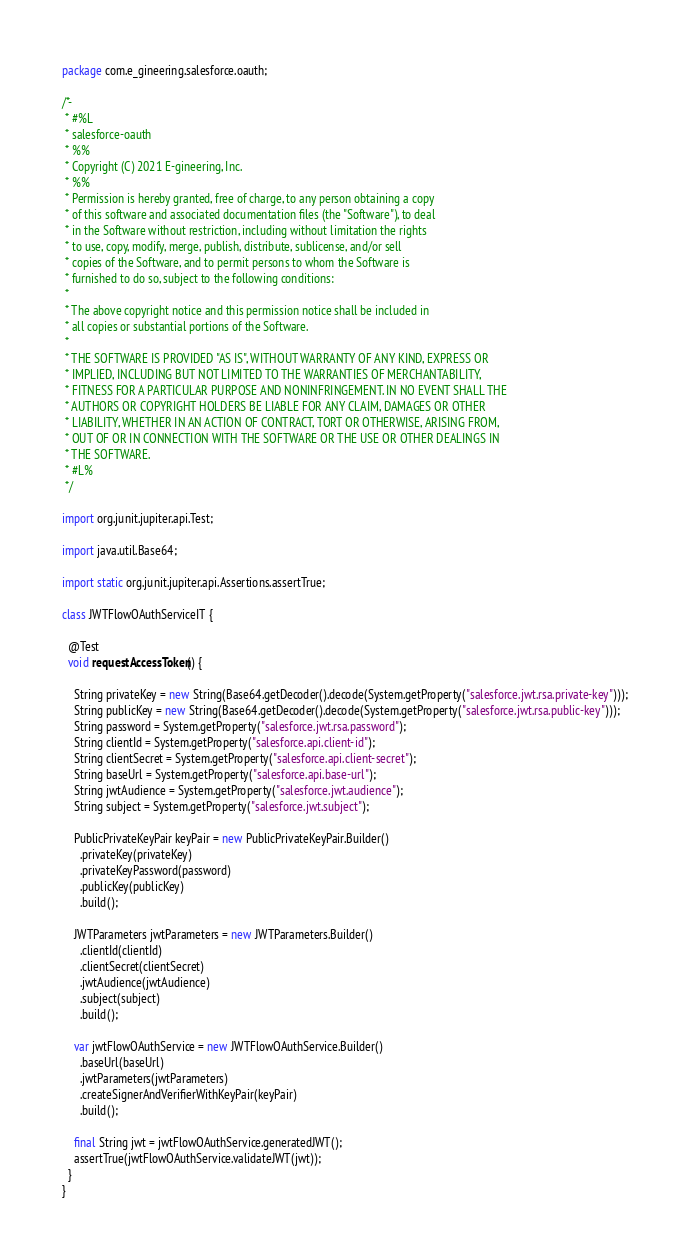<code> <loc_0><loc_0><loc_500><loc_500><_Java_>package com.e_gineering.salesforce.oauth;

/*-
 * #%L
 * salesforce-oauth
 * %%
 * Copyright (C) 2021 E-gineering, Inc.
 * %%
 * Permission is hereby granted, free of charge, to any person obtaining a copy
 * of this software and associated documentation files (the "Software"), to deal
 * in the Software without restriction, including without limitation the rights
 * to use, copy, modify, merge, publish, distribute, sublicense, and/or sell
 * copies of the Software, and to permit persons to whom the Software is
 * furnished to do so, subject to the following conditions:
 *
 * The above copyright notice and this permission notice shall be included in
 * all copies or substantial portions of the Software.
 *
 * THE SOFTWARE IS PROVIDED "AS IS", WITHOUT WARRANTY OF ANY KIND, EXPRESS OR
 * IMPLIED, INCLUDING BUT NOT LIMITED TO THE WARRANTIES OF MERCHANTABILITY,
 * FITNESS FOR A PARTICULAR PURPOSE AND NONINFRINGEMENT. IN NO EVENT SHALL THE
 * AUTHORS OR COPYRIGHT HOLDERS BE LIABLE FOR ANY CLAIM, DAMAGES OR OTHER
 * LIABILITY, WHETHER IN AN ACTION OF CONTRACT, TORT OR OTHERWISE, ARISING FROM,
 * OUT OF OR IN CONNECTION WITH THE SOFTWARE OR THE USE OR OTHER DEALINGS IN
 * THE SOFTWARE.
 * #L%
 */

import org.junit.jupiter.api.Test;

import java.util.Base64;

import static org.junit.jupiter.api.Assertions.assertTrue;

class JWTFlowOAuthServiceIT {

  @Test
  void requestAccessToken() {

    String privateKey = new String(Base64.getDecoder().decode(System.getProperty("salesforce.jwt.rsa.private-key")));
    String publicKey = new String(Base64.getDecoder().decode(System.getProperty("salesforce.jwt.rsa.public-key")));
    String password = System.getProperty("salesforce.jwt.rsa.password");
    String clientId = System.getProperty("salesforce.api.client-id");
    String clientSecret = System.getProperty("salesforce.api.client-secret");
    String baseUrl = System.getProperty("salesforce.api.base-url");
    String jwtAudience = System.getProperty("salesforce.jwt.audience");
    String subject = System.getProperty("salesforce.jwt.subject");

    PublicPrivateKeyPair keyPair = new PublicPrivateKeyPair.Builder()
      .privateKey(privateKey)
      .privateKeyPassword(password)
      .publicKey(publicKey)
      .build();

    JWTParameters jwtParameters = new JWTParameters.Builder()
      .clientId(clientId)
      .clientSecret(clientSecret)
      .jwtAudience(jwtAudience)
      .subject(subject)
      .build();

    var jwtFlowOAuthService = new JWTFlowOAuthService.Builder()
      .baseUrl(baseUrl)
      .jwtParameters(jwtParameters)
      .createSignerAndVerifierWithKeyPair(keyPair)
      .build();

    final String jwt = jwtFlowOAuthService.generatedJWT();
    assertTrue(jwtFlowOAuthService.validateJWT(jwt));
  }
}
</code> 